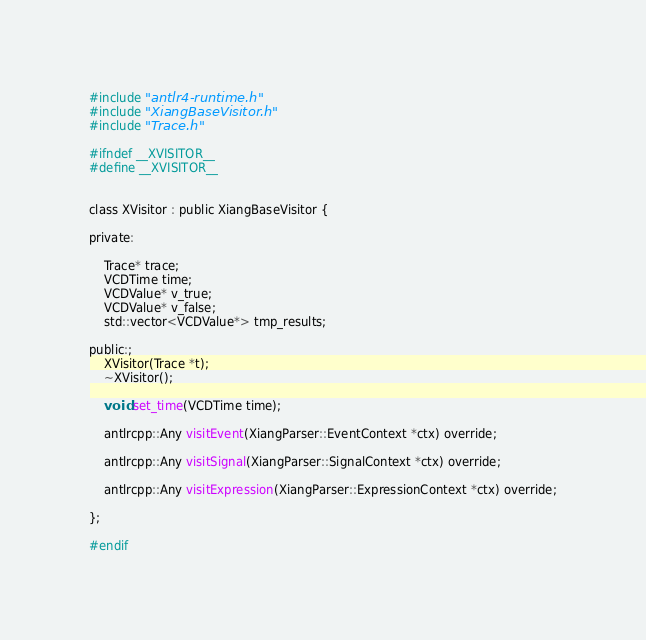Convert code to text. <code><loc_0><loc_0><loc_500><loc_500><_C_>#include "antlr4-runtime.h"
#include "XiangBaseVisitor.h"
#include "Trace.h"

#ifndef __XVISITOR__
#define __XVISITOR__


class XVisitor : public XiangBaseVisitor {

private:

    Trace* trace;
    VCDTime time;
    VCDValue* v_true;
    VCDValue* v_false;
    std::vector<VCDValue*> tmp_results;

public:;
    XVisitor(Trace *t);
    ~XVisitor();

    void set_time(VCDTime time);

    antlrcpp::Any visitEvent(XiangParser::EventContext *ctx) override;

    antlrcpp::Any visitSignal(XiangParser::SignalContext *ctx) override;

    antlrcpp::Any visitExpression(XiangParser::ExpressionContext *ctx) override;

};

#endif
</code> 